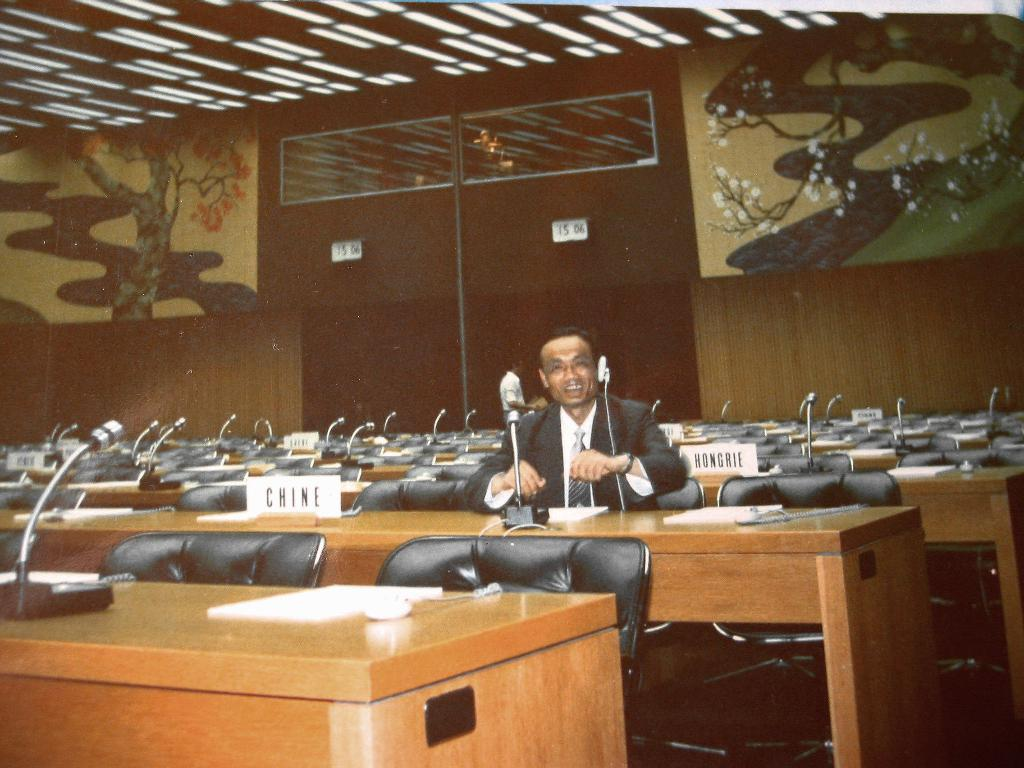What type of room is depicted in the image? There is a conference hall in the image. What features are present in the conference hall? The conference hall has microphones, chairs, lights, and a wall designed with trees. Can you describe the person in the conference hall? There is a person sitting in the conference hall, and they are smiling. What type of vegetable is being served in the conference hall? There is no vegetable present in the image; it depicts a conference hall with chairs, microphones, lights, and a person sitting and smiling. What brand of soda is being consumed by the person in the conference hall? There is no soda present in the image; the person is simply sitting and smiling. 